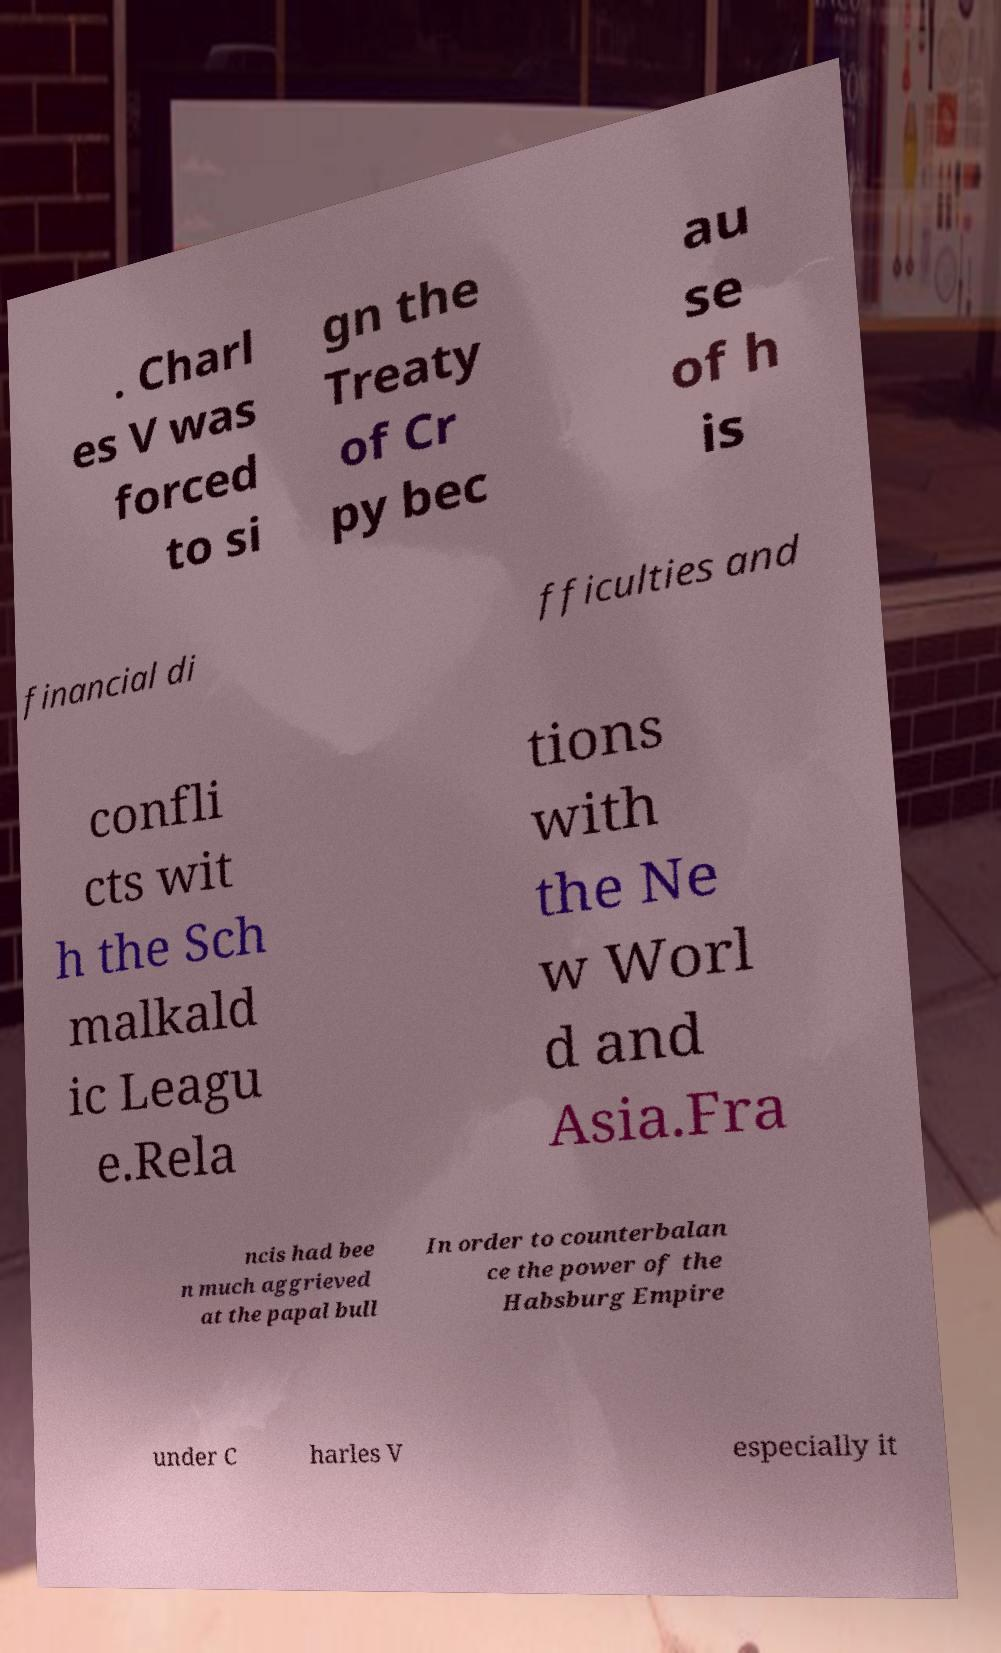For documentation purposes, I need the text within this image transcribed. Could you provide that? . Charl es V was forced to si gn the Treaty of Cr py bec au se of h is financial di fficulties and confli cts wit h the Sch malkald ic Leagu e.Rela tions with the Ne w Worl d and Asia.Fra ncis had bee n much aggrieved at the papal bull In order to counterbalan ce the power of the Habsburg Empire under C harles V especially it 